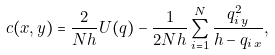Convert formula to latex. <formula><loc_0><loc_0><loc_500><loc_500>c ( x , y ) = \frac { 2 } { N h } U ( q ) - \frac { 1 } { 2 N h } \sum _ { i = 1 } ^ { N } \frac { q _ { i \, y } ^ { 2 } } { h - q _ { i \, x } } ,</formula> 